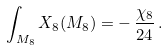Convert formula to latex. <formula><loc_0><loc_0><loc_500><loc_500>\int _ { M _ { 8 } } X _ { 8 } ( M _ { 8 } ) = - \, \frac { \chi _ { 8 } } { 2 4 } \, .</formula> 